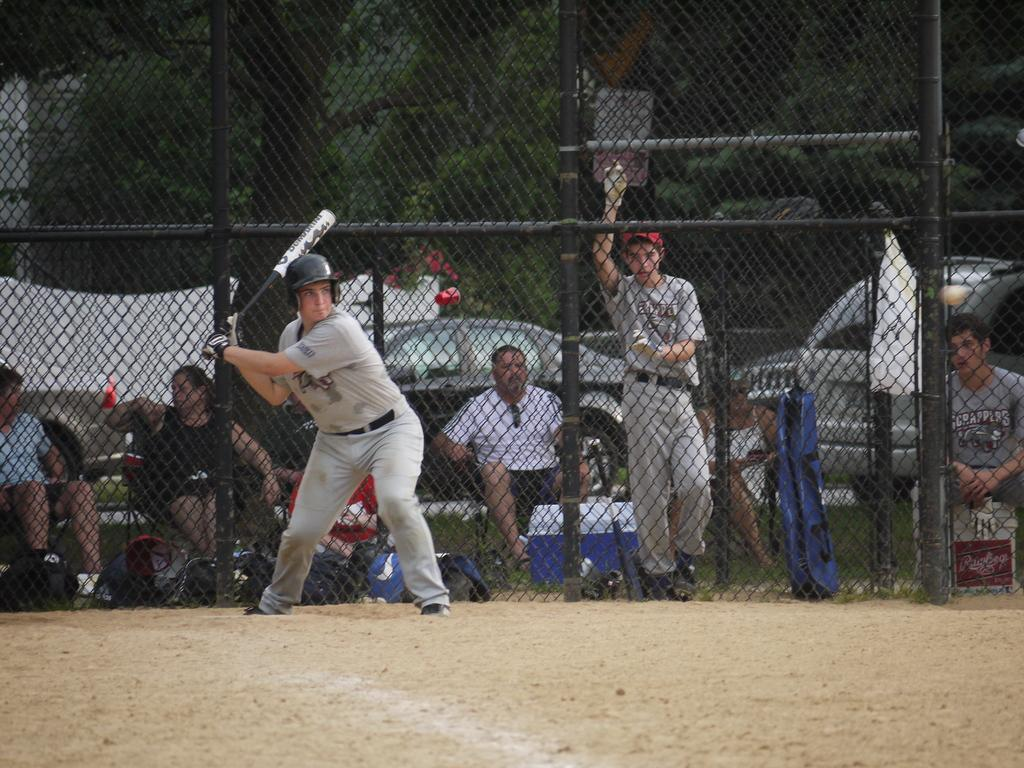What is the main subject of the image? There is a person in the image. What can be seen in the background of the image? There is a fence, trees, other persons, vehicles, and other objects in the background of the image. What type of surface is at the bottom of the image? There is a rocky surface at the bottom of the image. What type of collar can be seen on the person in the image? There is no collar visible on the person in the image. Can you see a sail in the image? There is no sail present in the image. 